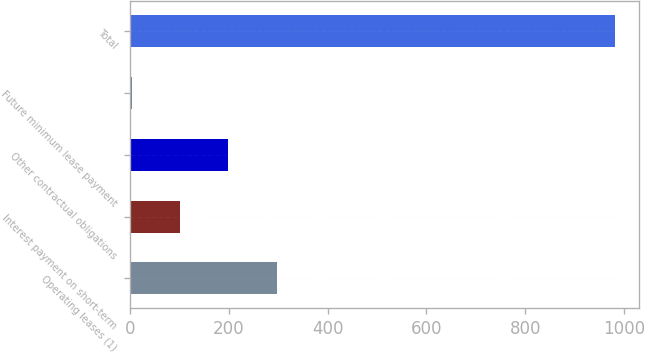Convert chart to OTSL. <chart><loc_0><loc_0><loc_500><loc_500><bar_chart><fcel>Operating leases (1)<fcel>Interest payment on short-term<fcel>Other contractual obligations<fcel>Future minimum lease payment<fcel>Total<nl><fcel>296.21<fcel>100.47<fcel>198.34<fcel>2.6<fcel>981.3<nl></chart> 